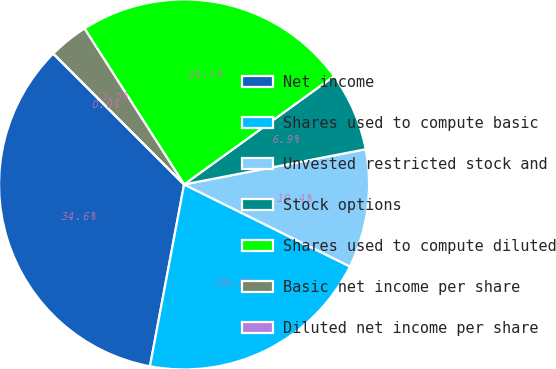<chart> <loc_0><loc_0><loc_500><loc_500><pie_chart><fcel>Net income<fcel>Shares used to compute basic<fcel>Unvested restricted stock and<fcel>Stock options<fcel>Shares used to compute diluted<fcel>Basic net income per share<fcel>Diluted net income per share<nl><fcel>34.55%<fcel>20.64%<fcel>10.36%<fcel>6.91%<fcel>24.09%<fcel>3.45%<fcel>0.0%<nl></chart> 